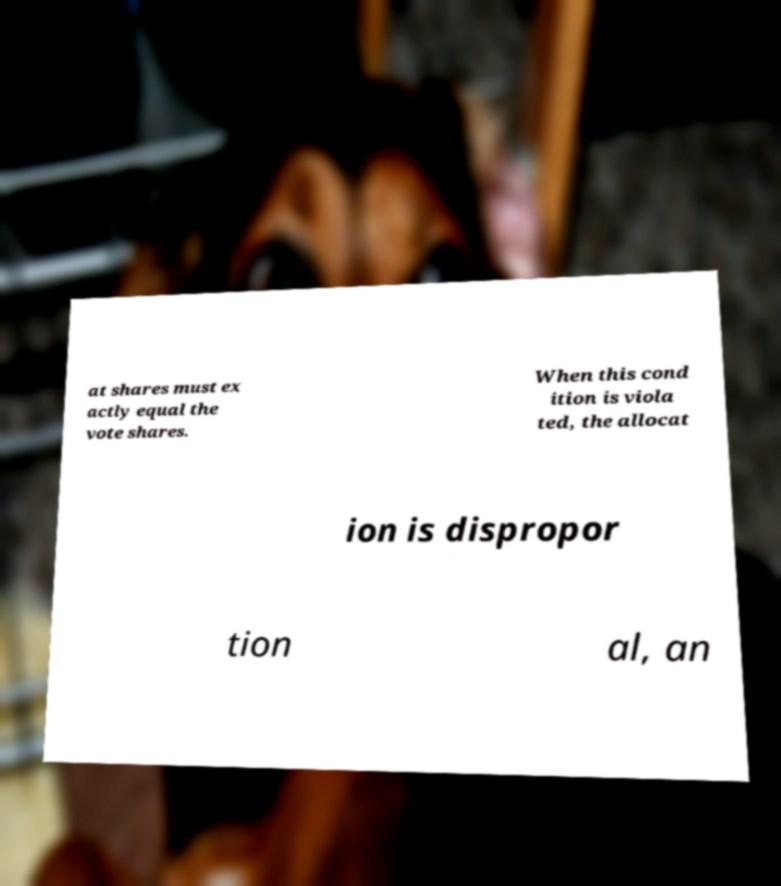Can you read and provide the text displayed in the image?This photo seems to have some interesting text. Can you extract and type it out for me? at shares must ex actly equal the vote shares. When this cond ition is viola ted, the allocat ion is dispropor tion al, an 